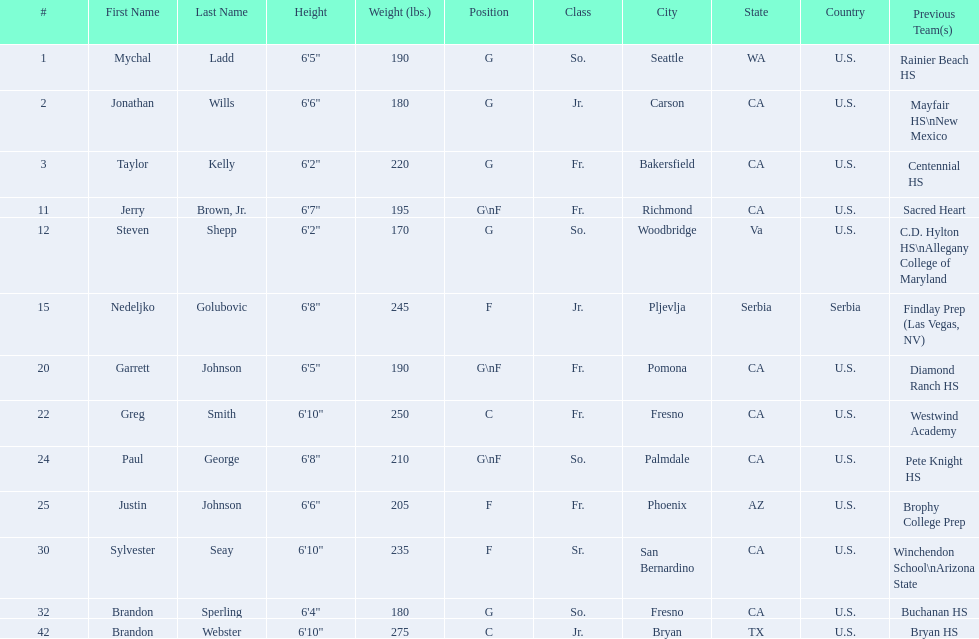Who are the players for the 2009-10 fresno state bulldogs men's basketball team? Mychal Ladd, Jonathan Wills, Taylor Kelly, Jerry Brown, Jr., Steven Shepp, Nedeljko Golubovic, Garrett Johnson, Greg Smith, Paul George, Justin Johnson, Sylvester Seay, Brandon Sperling, Brandon Webster. What are their heights? 6'5", 6'6", 6'2", 6'7", 6'2", 6'8", 6'5", 6'10", 6'8", 6'6", 6'10", 6'4", 6'10". What is the shortest height? 6'2", 6'2". What is the lowest weight? 6'2". Which player is it? Steven Shepp. 